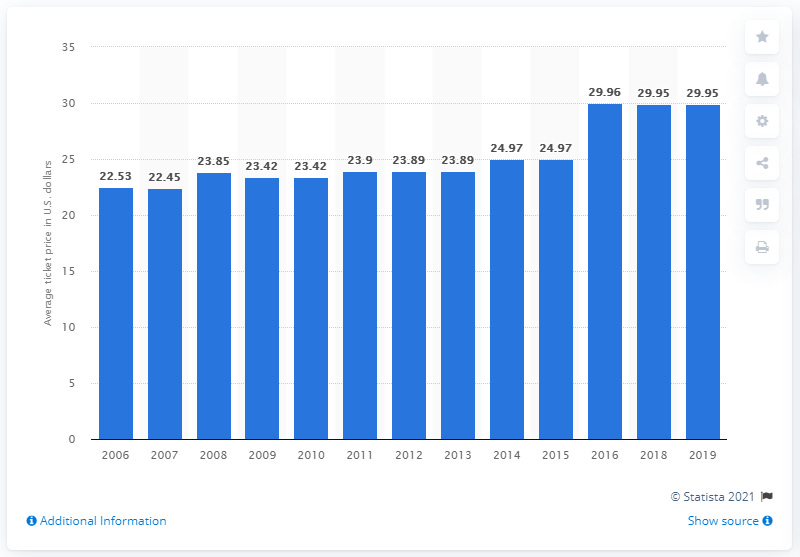Point out several critical features in this image. The average ticket price for Baltimore Orioles games in 2019 was 29.95. 